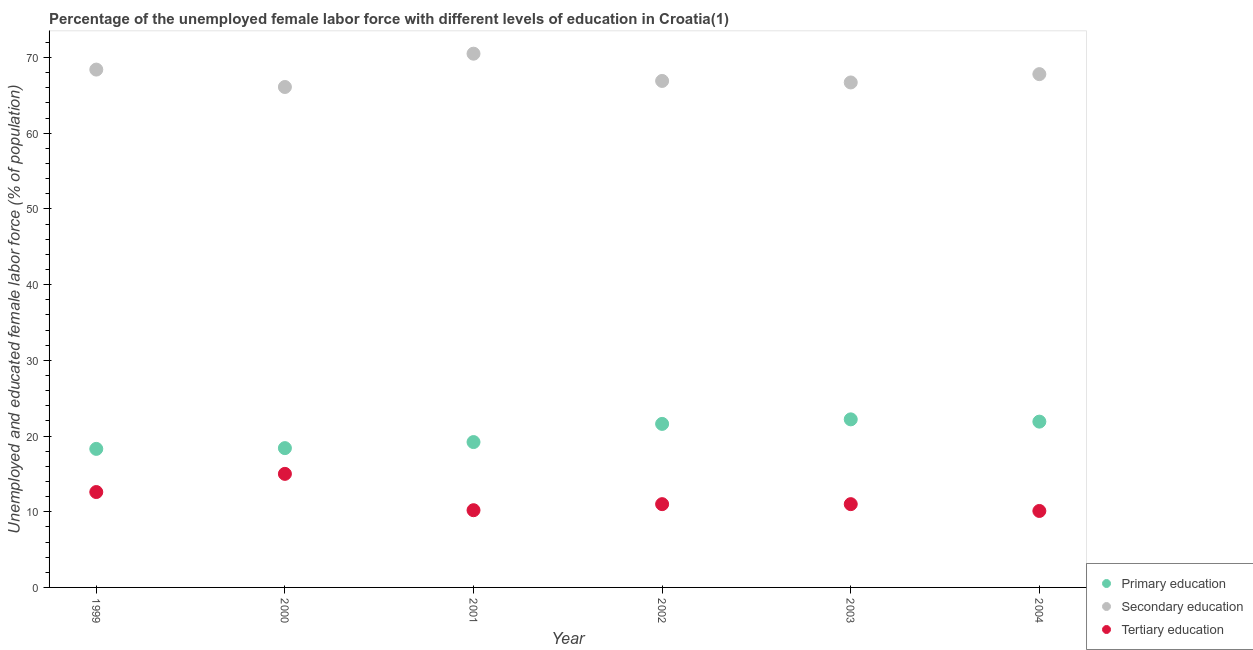What is the percentage of female labor force who received primary education in 1999?
Offer a terse response. 18.3. Across all years, what is the maximum percentage of female labor force who received tertiary education?
Provide a short and direct response. 15. Across all years, what is the minimum percentage of female labor force who received tertiary education?
Provide a short and direct response. 10.1. In which year was the percentage of female labor force who received secondary education minimum?
Provide a succinct answer. 2000. What is the total percentage of female labor force who received secondary education in the graph?
Keep it short and to the point. 406.4. What is the difference between the percentage of female labor force who received secondary education in 2001 and that in 2002?
Your response must be concise. 3.6. What is the difference between the percentage of female labor force who received tertiary education in 2003 and the percentage of female labor force who received secondary education in 2000?
Offer a terse response. -55.1. What is the average percentage of female labor force who received tertiary education per year?
Your response must be concise. 11.65. In the year 2003, what is the difference between the percentage of female labor force who received primary education and percentage of female labor force who received secondary education?
Your response must be concise. -44.5. In how many years, is the percentage of female labor force who received secondary education greater than 10 %?
Make the answer very short. 6. What is the ratio of the percentage of female labor force who received secondary education in 2000 to that in 2004?
Provide a short and direct response. 0.97. Is the percentage of female labor force who received tertiary education in 2000 less than that in 2002?
Provide a succinct answer. No. What is the difference between the highest and the second highest percentage of female labor force who received primary education?
Your response must be concise. 0.3. What is the difference between the highest and the lowest percentage of female labor force who received tertiary education?
Make the answer very short. 4.9. In how many years, is the percentage of female labor force who received secondary education greater than the average percentage of female labor force who received secondary education taken over all years?
Provide a short and direct response. 3. Is it the case that in every year, the sum of the percentage of female labor force who received primary education and percentage of female labor force who received secondary education is greater than the percentage of female labor force who received tertiary education?
Provide a succinct answer. Yes. Is the percentage of female labor force who received tertiary education strictly less than the percentage of female labor force who received primary education over the years?
Make the answer very short. Yes. How many legend labels are there?
Your answer should be compact. 3. How are the legend labels stacked?
Provide a short and direct response. Vertical. What is the title of the graph?
Give a very brief answer. Percentage of the unemployed female labor force with different levels of education in Croatia(1). Does "Social Protection and Labor" appear as one of the legend labels in the graph?
Offer a very short reply. No. What is the label or title of the Y-axis?
Provide a succinct answer. Unemployed and educated female labor force (% of population). What is the Unemployed and educated female labor force (% of population) of Primary education in 1999?
Offer a very short reply. 18.3. What is the Unemployed and educated female labor force (% of population) in Secondary education in 1999?
Ensure brevity in your answer.  68.4. What is the Unemployed and educated female labor force (% of population) in Tertiary education in 1999?
Keep it short and to the point. 12.6. What is the Unemployed and educated female labor force (% of population) in Primary education in 2000?
Offer a very short reply. 18.4. What is the Unemployed and educated female labor force (% of population) of Secondary education in 2000?
Offer a very short reply. 66.1. What is the Unemployed and educated female labor force (% of population) in Tertiary education in 2000?
Your answer should be very brief. 15. What is the Unemployed and educated female labor force (% of population) in Primary education in 2001?
Provide a short and direct response. 19.2. What is the Unemployed and educated female labor force (% of population) of Secondary education in 2001?
Ensure brevity in your answer.  70.5. What is the Unemployed and educated female labor force (% of population) in Tertiary education in 2001?
Your response must be concise. 10.2. What is the Unemployed and educated female labor force (% of population) of Primary education in 2002?
Offer a very short reply. 21.6. What is the Unemployed and educated female labor force (% of population) of Secondary education in 2002?
Give a very brief answer. 66.9. What is the Unemployed and educated female labor force (% of population) in Primary education in 2003?
Give a very brief answer. 22.2. What is the Unemployed and educated female labor force (% of population) in Secondary education in 2003?
Give a very brief answer. 66.7. What is the Unemployed and educated female labor force (% of population) of Tertiary education in 2003?
Give a very brief answer. 11. What is the Unemployed and educated female labor force (% of population) in Primary education in 2004?
Make the answer very short. 21.9. What is the Unemployed and educated female labor force (% of population) in Secondary education in 2004?
Your answer should be compact. 67.8. What is the Unemployed and educated female labor force (% of population) in Tertiary education in 2004?
Your answer should be compact. 10.1. Across all years, what is the maximum Unemployed and educated female labor force (% of population) in Primary education?
Offer a very short reply. 22.2. Across all years, what is the maximum Unemployed and educated female labor force (% of population) in Secondary education?
Ensure brevity in your answer.  70.5. Across all years, what is the minimum Unemployed and educated female labor force (% of population) of Primary education?
Give a very brief answer. 18.3. Across all years, what is the minimum Unemployed and educated female labor force (% of population) of Secondary education?
Offer a terse response. 66.1. Across all years, what is the minimum Unemployed and educated female labor force (% of population) in Tertiary education?
Your response must be concise. 10.1. What is the total Unemployed and educated female labor force (% of population) in Primary education in the graph?
Your response must be concise. 121.6. What is the total Unemployed and educated female labor force (% of population) in Secondary education in the graph?
Your response must be concise. 406.4. What is the total Unemployed and educated female labor force (% of population) of Tertiary education in the graph?
Provide a short and direct response. 69.9. What is the difference between the Unemployed and educated female labor force (% of population) in Primary education in 1999 and that in 2000?
Give a very brief answer. -0.1. What is the difference between the Unemployed and educated female labor force (% of population) of Tertiary education in 1999 and that in 2000?
Your answer should be compact. -2.4. What is the difference between the Unemployed and educated female labor force (% of population) of Secondary education in 1999 and that in 2001?
Provide a succinct answer. -2.1. What is the difference between the Unemployed and educated female labor force (% of population) in Secondary education in 1999 and that in 2002?
Ensure brevity in your answer.  1.5. What is the difference between the Unemployed and educated female labor force (% of population) in Primary education in 1999 and that in 2003?
Your response must be concise. -3.9. What is the difference between the Unemployed and educated female labor force (% of population) in Tertiary education in 1999 and that in 2003?
Your response must be concise. 1.6. What is the difference between the Unemployed and educated female labor force (% of population) in Secondary education in 1999 and that in 2004?
Your response must be concise. 0.6. What is the difference between the Unemployed and educated female labor force (% of population) in Tertiary education in 1999 and that in 2004?
Your response must be concise. 2.5. What is the difference between the Unemployed and educated female labor force (% of population) of Primary education in 2000 and that in 2001?
Provide a succinct answer. -0.8. What is the difference between the Unemployed and educated female labor force (% of population) of Primary education in 2000 and that in 2002?
Provide a succinct answer. -3.2. What is the difference between the Unemployed and educated female labor force (% of population) in Primary education in 2000 and that in 2003?
Give a very brief answer. -3.8. What is the difference between the Unemployed and educated female labor force (% of population) in Tertiary education in 2000 and that in 2003?
Your response must be concise. 4. What is the difference between the Unemployed and educated female labor force (% of population) in Primary education in 2000 and that in 2004?
Provide a short and direct response. -3.5. What is the difference between the Unemployed and educated female labor force (% of population) in Secondary education in 2000 and that in 2004?
Make the answer very short. -1.7. What is the difference between the Unemployed and educated female labor force (% of population) of Tertiary education in 2000 and that in 2004?
Keep it short and to the point. 4.9. What is the difference between the Unemployed and educated female labor force (% of population) of Primary education in 2001 and that in 2002?
Keep it short and to the point. -2.4. What is the difference between the Unemployed and educated female labor force (% of population) in Secondary education in 2001 and that in 2002?
Make the answer very short. 3.6. What is the difference between the Unemployed and educated female labor force (% of population) of Tertiary education in 2001 and that in 2003?
Your response must be concise. -0.8. What is the difference between the Unemployed and educated female labor force (% of population) of Secondary education in 2001 and that in 2004?
Keep it short and to the point. 2.7. What is the difference between the Unemployed and educated female labor force (% of population) in Tertiary education in 2001 and that in 2004?
Provide a succinct answer. 0.1. What is the difference between the Unemployed and educated female labor force (% of population) of Primary education in 2002 and that in 2004?
Your answer should be compact. -0.3. What is the difference between the Unemployed and educated female labor force (% of population) in Secondary education in 2002 and that in 2004?
Your response must be concise. -0.9. What is the difference between the Unemployed and educated female labor force (% of population) in Tertiary education in 2002 and that in 2004?
Offer a terse response. 0.9. What is the difference between the Unemployed and educated female labor force (% of population) in Secondary education in 2003 and that in 2004?
Provide a succinct answer. -1.1. What is the difference between the Unemployed and educated female labor force (% of population) in Tertiary education in 2003 and that in 2004?
Give a very brief answer. 0.9. What is the difference between the Unemployed and educated female labor force (% of population) in Primary education in 1999 and the Unemployed and educated female labor force (% of population) in Secondary education in 2000?
Your answer should be very brief. -47.8. What is the difference between the Unemployed and educated female labor force (% of population) in Primary education in 1999 and the Unemployed and educated female labor force (% of population) in Tertiary education in 2000?
Offer a very short reply. 3.3. What is the difference between the Unemployed and educated female labor force (% of population) of Secondary education in 1999 and the Unemployed and educated female labor force (% of population) of Tertiary education in 2000?
Offer a very short reply. 53.4. What is the difference between the Unemployed and educated female labor force (% of population) of Primary education in 1999 and the Unemployed and educated female labor force (% of population) of Secondary education in 2001?
Provide a succinct answer. -52.2. What is the difference between the Unemployed and educated female labor force (% of population) of Primary education in 1999 and the Unemployed and educated female labor force (% of population) of Tertiary education in 2001?
Ensure brevity in your answer.  8.1. What is the difference between the Unemployed and educated female labor force (% of population) in Secondary education in 1999 and the Unemployed and educated female labor force (% of population) in Tertiary education in 2001?
Give a very brief answer. 58.2. What is the difference between the Unemployed and educated female labor force (% of population) in Primary education in 1999 and the Unemployed and educated female labor force (% of population) in Secondary education in 2002?
Make the answer very short. -48.6. What is the difference between the Unemployed and educated female labor force (% of population) of Secondary education in 1999 and the Unemployed and educated female labor force (% of population) of Tertiary education in 2002?
Offer a very short reply. 57.4. What is the difference between the Unemployed and educated female labor force (% of population) of Primary education in 1999 and the Unemployed and educated female labor force (% of population) of Secondary education in 2003?
Provide a short and direct response. -48.4. What is the difference between the Unemployed and educated female labor force (% of population) of Secondary education in 1999 and the Unemployed and educated female labor force (% of population) of Tertiary education in 2003?
Your response must be concise. 57.4. What is the difference between the Unemployed and educated female labor force (% of population) of Primary education in 1999 and the Unemployed and educated female labor force (% of population) of Secondary education in 2004?
Keep it short and to the point. -49.5. What is the difference between the Unemployed and educated female labor force (% of population) in Primary education in 1999 and the Unemployed and educated female labor force (% of population) in Tertiary education in 2004?
Your answer should be very brief. 8.2. What is the difference between the Unemployed and educated female labor force (% of population) of Secondary education in 1999 and the Unemployed and educated female labor force (% of population) of Tertiary education in 2004?
Keep it short and to the point. 58.3. What is the difference between the Unemployed and educated female labor force (% of population) of Primary education in 2000 and the Unemployed and educated female labor force (% of population) of Secondary education in 2001?
Keep it short and to the point. -52.1. What is the difference between the Unemployed and educated female labor force (% of population) in Primary education in 2000 and the Unemployed and educated female labor force (% of population) in Tertiary education in 2001?
Keep it short and to the point. 8.2. What is the difference between the Unemployed and educated female labor force (% of population) in Secondary education in 2000 and the Unemployed and educated female labor force (% of population) in Tertiary education in 2001?
Your response must be concise. 55.9. What is the difference between the Unemployed and educated female labor force (% of population) in Primary education in 2000 and the Unemployed and educated female labor force (% of population) in Secondary education in 2002?
Make the answer very short. -48.5. What is the difference between the Unemployed and educated female labor force (% of population) of Primary education in 2000 and the Unemployed and educated female labor force (% of population) of Tertiary education in 2002?
Your answer should be very brief. 7.4. What is the difference between the Unemployed and educated female labor force (% of population) in Secondary education in 2000 and the Unemployed and educated female labor force (% of population) in Tertiary education in 2002?
Keep it short and to the point. 55.1. What is the difference between the Unemployed and educated female labor force (% of population) in Primary education in 2000 and the Unemployed and educated female labor force (% of population) in Secondary education in 2003?
Offer a terse response. -48.3. What is the difference between the Unemployed and educated female labor force (% of population) in Secondary education in 2000 and the Unemployed and educated female labor force (% of population) in Tertiary education in 2003?
Your response must be concise. 55.1. What is the difference between the Unemployed and educated female labor force (% of population) in Primary education in 2000 and the Unemployed and educated female labor force (% of population) in Secondary education in 2004?
Ensure brevity in your answer.  -49.4. What is the difference between the Unemployed and educated female labor force (% of population) in Secondary education in 2000 and the Unemployed and educated female labor force (% of population) in Tertiary education in 2004?
Provide a succinct answer. 56. What is the difference between the Unemployed and educated female labor force (% of population) in Primary education in 2001 and the Unemployed and educated female labor force (% of population) in Secondary education in 2002?
Ensure brevity in your answer.  -47.7. What is the difference between the Unemployed and educated female labor force (% of population) in Secondary education in 2001 and the Unemployed and educated female labor force (% of population) in Tertiary education in 2002?
Offer a very short reply. 59.5. What is the difference between the Unemployed and educated female labor force (% of population) in Primary education in 2001 and the Unemployed and educated female labor force (% of population) in Secondary education in 2003?
Offer a very short reply. -47.5. What is the difference between the Unemployed and educated female labor force (% of population) of Secondary education in 2001 and the Unemployed and educated female labor force (% of population) of Tertiary education in 2003?
Your response must be concise. 59.5. What is the difference between the Unemployed and educated female labor force (% of population) of Primary education in 2001 and the Unemployed and educated female labor force (% of population) of Secondary education in 2004?
Keep it short and to the point. -48.6. What is the difference between the Unemployed and educated female labor force (% of population) in Secondary education in 2001 and the Unemployed and educated female labor force (% of population) in Tertiary education in 2004?
Your answer should be compact. 60.4. What is the difference between the Unemployed and educated female labor force (% of population) in Primary education in 2002 and the Unemployed and educated female labor force (% of population) in Secondary education in 2003?
Your answer should be very brief. -45.1. What is the difference between the Unemployed and educated female labor force (% of population) of Primary education in 2002 and the Unemployed and educated female labor force (% of population) of Tertiary education in 2003?
Your response must be concise. 10.6. What is the difference between the Unemployed and educated female labor force (% of population) of Secondary education in 2002 and the Unemployed and educated female labor force (% of population) of Tertiary education in 2003?
Offer a very short reply. 55.9. What is the difference between the Unemployed and educated female labor force (% of population) of Primary education in 2002 and the Unemployed and educated female labor force (% of population) of Secondary education in 2004?
Provide a short and direct response. -46.2. What is the difference between the Unemployed and educated female labor force (% of population) in Secondary education in 2002 and the Unemployed and educated female labor force (% of population) in Tertiary education in 2004?
Your answer should be compact. 56.8. What is the difference between the Unemployed and educated female labor force (% of population) in Primary education in 2003 and the Unemployed and educated female labor force (% of population) in Secondary education in 2004?
Provide a short and direct response. -45.6. What is the difference between the Unemployed and educated female labor force (% of population) of Primary education in 2003 and the Unemployed and educated female labor force (% of population) of Tertiary education in 2004?
Keep it short and to the point. 12.1. What is the difference between the Unemployed and educated female labor force (% of population) of Secondary education in 2003 and the Unemployed and educated female labor force (% of population) of Tertiary education in 2004?
Offer a very short reply. 56.6. What is the average Unemployed and educated female labor force (% of population) of Primary education per year?
Your answer should be very brief. 20.27. What is the average Unemployed and educated female labor force (% of population) of Secondary education per year?
Your response must be concise. 67.73. What is the average Unemployed and educated female labor force (% of population) of Tertiary education per year?
Your answer should be very brief. 11.65. In the year 1999, what is the difference between the Unemployed and educated female labor force (% of population) in Primary education and Unemployed and educated female labor force (% of population) in Secondary education?
Give a very brief answer. -50.1. In the year 1999, what is the difference between the Unemployed and educated female labor force (% of population) of Secondary education and Unemployed and educated female labor force (% of population) of Tertiary education?
Ensure brevity in your answer.  55.8. In the year 2000, what is the difference between the Unemployed and educated female labor force (% of population) of Primary education and Unemployed and educated female labor force (% of population) of Secondary education?
Provide a succinct answer. -47.7. In the year 2000, what is the difference between the Unemployed and educated female labor force (% of population) of Secondary education and Unemployed and educated female labor force (% of population) of Tertiary education?
Your answer should be compact. 51.1. In the year 2001, what is the difference between the Unemployed and educated female labor force (% of population) of Primary education and Unemployed and educated female labor force (% of population) of Secondary education?
Make the answer very short. -51.3. In the year 2001, what is the difference between the Unemployed and educated female labor force (% of population) of Secondary education and Unemployed and educated female labor force (% of population) of Tertiary education?
Your response must be concise. 60.3. In the year 2002, what is the difference between the Unemployed and educated female labor force (% of population) of Primary education and Unemployed and educated female labor force (% of population) of Secondary education?
Your answer should be very brief. -45.3. In the year 2002, what is the difference between the Unemployed and educated female labor force (% of population) of Secondary education and Unemployed and educated female labor force (% of population) of Tertiary education?
Offer a very short reply. 55.9. In the year 2003, what is the difference between the Unemployed and educated female labor force (% of population) of Primary education and Unemployed and educated female labor force (% of population) of Secondary education?
Ensure brevity in your answer.  -44.5. In the year 2003, what is the difference between the Unemployed and educated female labor force (% of population) of Primary education and Unemployed and educated female labor force (% of population) of Tertiary education?
Ensure brevity in your answer.  11.2. In the year 2003, what is the difference between the Unemployed and educated female labor force (% of population) in Secondary education and Unemployed and educated female labor force (% of population) in Tertiary education?
Keep it short and to the point. 55.7. In the year 2004, what is the difference between the Unemployed and educated female labor force (% of population) in Primary education and Unemployed and educated female labor force (% of population) in Secondary education?
Keep it short and to the point. -45.9. In the year 2004, what is the difference between the Unemployed and educated female labor force (% of population) of Primary education and Unemployed and educated female labor force (% of population) of Tertiary education?
Offer a terse response. 11.8. In the year 2004, what is the difference between the Unemployed and educated female labor force (% of population) in Secondary education and Unemployed and educated female labor force (% of population) in Tertiary education?
Your answer should be very brief. 57.7. What is the ratio of the Unemployed and educated female labor force (% of population) in Primary education in 1999 to that in 2000?
Provide a succinct answer. 0.99. What is the ratio of the Unemployed and educated female labor force (% of population) in Secondary education in 1999 to that in 2000?
Offer a very short reply. 1.03. What is the ratio of the Unemployed and educated female labor force (% of population) of Tertiary education in 1999 to that in 2000?
Ensure brevity in your answer.  0.84. What is the ratio of the Unemployed and educated female labor force (% of population) of Primary education in 1999 to that in 2001?
Ensure brevity in your answer.  0.95. What is the ratio of the Unemployed and educated female labor force (% of population) in Secondary education in 1999 to that in 2001?
Provide a short and direct response. 0.97. What is the ratio of the Unemployed and educated female labor force (% of population) of Tertiary education in 1999 to that in 2001?
Give a very brief answer. 1.24. What is the ratio of the Unemployed and educated female labor force (% of population) of Primary education in 1999 to that in 2002?
Make the answer very short. 0.85. What is the ratio of the Unemployed and educated female labor force (% of population) in Secondary education in 1999 to that in 2002?
Ensure brevity in your answer.  1.02. What is the ratio of the Unemployed and educated female labor force (% of population) of Tertiary education in 1999 to that in 2002?
Your answer should be compact. 1.15. What is the ratio of the Unemployed and educated female labor force (% of population) in Primary education in 1999 to that in 2003?
Offer a very short reply. 0.82. What is the ratio of the Unemployed and educated female labor force (% of population) in Secondary education in 1999 to that in 2003?
Provide a succinct answer. 1.03. What is the ratio of the Unemployed and educated female labor force (% of population) in Tertiary education in 1999 to that in 2003?
Offer a very short reply. 1.15. What is the ratio of the Unemployed and educated female labor force (% of population) in Primary education in 1999 to that in 2004?
Offer a very short reply. 0.84. What is the ratio of the Unemployed and educated female labor force (% of population) of Secondary education in 1999 to that in 2004?
Ensure brevity in your answer.  1.01. What is the ratio of the Unemployed and educated female labor force (% of population) of Tertiary education in 1999 to that in 2004?
Provide a succinct answer. 1.25. What is the ratio of the Unemployed and educated female labor force (% of population) of Secondary education in 2000 to that in 2001?
Give a very brief answer. 0.94. What is the ratio of the Unemployed and educated female labor force (% of population) in Tertiary education in 2000 to that in 2001?
Your response must be concise. 1.47. What is the ratio of the Unemployed and educated female labor force (% of population) in Primary education in 2000 to that in 2002?
Your response must be concise. 0.85. What is the ratio of the Unemployed and educated female labor force (% of population) of Tertiary education in 2000 to that in 2002?
Make the answer very short. 1.36. What is the ratio of the Unemployed and educated female labor force (% of population) of Primary education in 2000 to that in 2003?
Offer a very short reply. 0.83. What is the ratio of the Unemployed and educated female labor force (% of population) of Tertiary education in 2000 to that in 2003?
Ensure brevity in your answer.  1.36. What is the ratio of the Unemployed and educated female labor force (% of population) of Primary education in 2000 to that in 2004?
Give a very brief answer. 0.84. What is the ratio of the Unemployed and educated female labor force (% of population) of Secondary education in 2000 to that in 2004?
Keep it short and to the point. 0.97. What is the ratio of the Unemployed and educated female labor force (% of population) in Tertiary education in 2000 to that in 2004?
Provide a succinct answer. 1.49. What is the ratio of the Unemployed and educated female labor force (% of population) in Primary education in 2001 to that in 2002?
Provide a short and direct response. 0.89. What is the ratio of the Unemployed and educated female labor force (% of population) of Secondary education in 2001 to that in 2002?
Your answer should be very brief. 1.05. What is the ratio of the Unemployed and educated female labor force (% of population) of Tertiary education in 2001 to that in 2002?
Your answer should be very brief. 0.93. What is the ratio of the Unemployed and educated female labor force (% of population) of Primary education in 2001 to that in 2003?
Give a very brief answer. 0.86. What is the ratio of the Unemployed and educated female labor force (% of population) in Secondary education in 2001 to that in 2003?
Make the answer very short. 1.06. What is the ratio of the Unemployed and educated female labor force (% of population) of Tertiary education in 2001 to that in 2003?
Your answer should be very brief. 0.93. What is the ratio of the Unemployed and educated female labor force (% of population) of Primary education in 2001 to that in 2004?
Your answer should be very brief. 0.88. What is the ratio of the Unemployed and educated female labor force (% of population) in Secondary education in 2001 to that in 2004?
Offer a very short reply. 1.04. What is the ratio of the Unemployed and educated female labor force (% of population) of Tertiary education in 2001 to that in 2004?
Your answer should be very brief. 1.01. What is the ratio of the Unemployed and educated female labor force (% of population) of Primary education in 2002 to that in 2003?
Ensure brevity in your answer.  0.97. What is the ratio of the Unemployed and educated female labor force (% of population) of Secondary education in 2002 to that in 2003?
Provide a succinct answer. 1. What is the ratio of the Unemployed and educated female labor force (% of population) in Primary education in 2002 to that in 2004?
Your answer should be compact. 0.99. What is the ratio of the Unemployed and educated female labor force (% of population) in Secondary education in 2002 to that in 2004?
Provide a short and direct response. 0.99. What is the ratio of the Unemployed and educated female labor force (% of population) in Tertiary education in 2002 to that in 2004?
Provide a short and direct response. 1.09. What is the ratio of the Unemployed and educated female labor force (% of population) in Primary education in 2003 to that in 2004?
Keep it short and to the point. 1.01. What is the ratio of the Unemployed and educated female labor force (% of population) of Secondary education in 2003 to that in 2004?
Keep it short and to the point. 0.98. What is the ratio of the Unemployed and educated female labor force (% of population) in Tertiary education in 2003 to that in 2004?
Keep it short and to the point. 1.09. What is the difference between the highest and the second highest Unemployed and educated female labor force (% of population) of Secondary education?
Your answer should be very brief. 2.1. What is the difference between the highest and the second highest Unemployed and educated female labor force (% of population) in Tertiary education?
Your answer should be compact. 2.4. What is the difference between the highest and the lowest Unemployed and educated female labor force (% of population) of Primary education?
Make the answer very short. 3.9. What is the difference between the highest and the lowest Unemployed and educated female labor force (% of population) of Secondary education?
Ensure brevity in your answer.  4.4. 